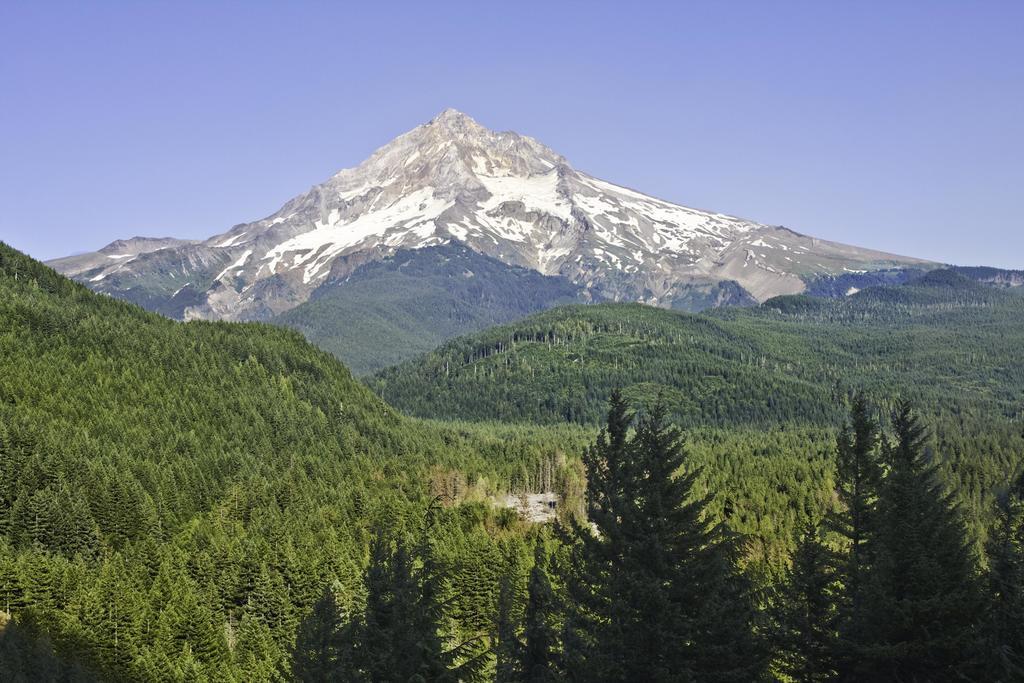Describe this image in one or two sentences. In this image I can see number of trees, mountain and the sky in background. 